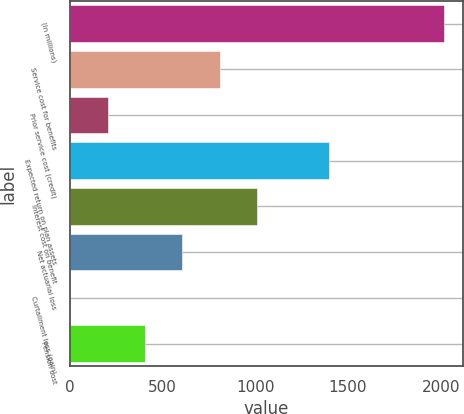<chart> <loc_0><loc_0><loc_500><loc_500><bar_chart><fcel>(In millions)<fcel>Service cost for benefits<fcel>Prior service cost (credit)<fcel>Expected return on plan assets<fcel>Interest cost on benefit<fcel>Net actuarial loss<fcel>Curtailment loss (gain)<fcel>Pension cost<nl><fcel>2018<fcel>809<fcel>204.5<fcel>1398<fcel>1010.5<fcel>607.5<fcel>3<fcel>406<nl></chart> 